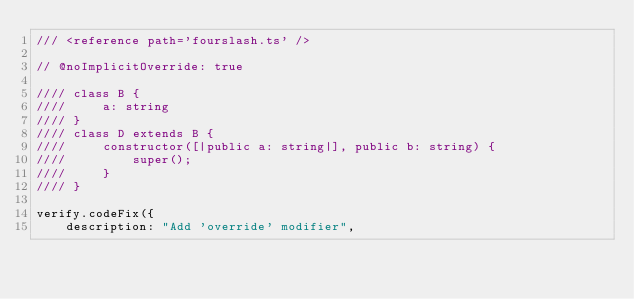<code> <loc_0><loc_0><loc_500><loc_500><_TypeScript_>/// <reference path='fourslash.ts' />

// @noImplicitOverride: true

//// class B {
////     a: string
//// }
//// class D extends B {
////     constructor([|public a: string|], public b: string) {
////         super();
////     }
//// }

verify.codeFix({
    description: "Add 'override' modifier",</code> 